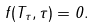<formula> <loc_0><loc_0><loc_500><loc_500>f ( T _ { \tau } , \tau ) = 0 .</formula> 